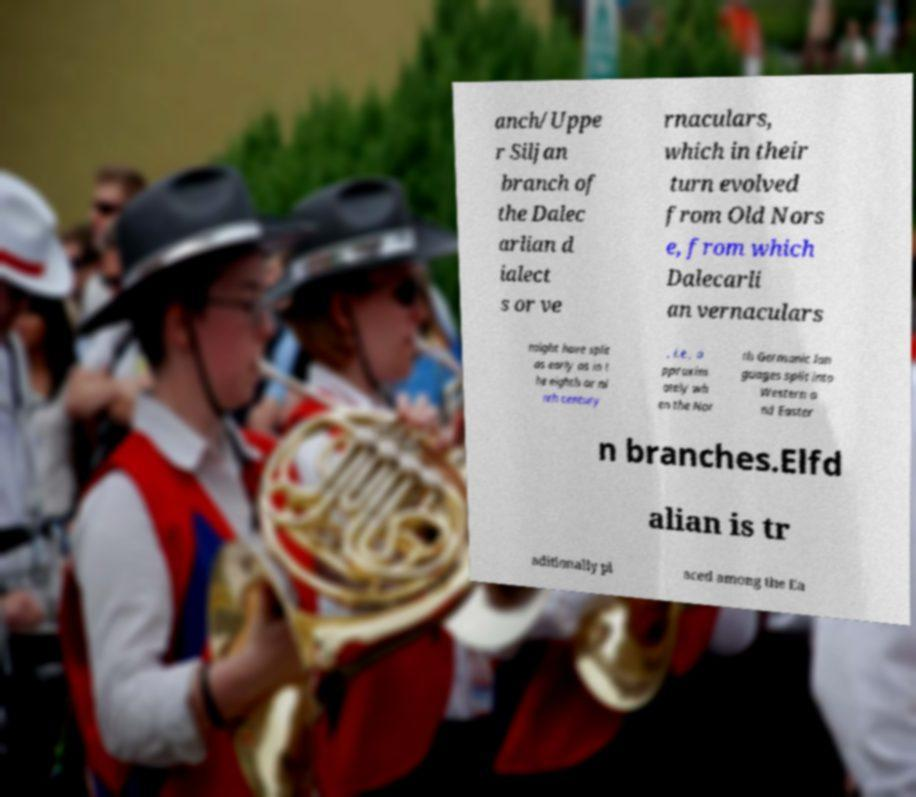Please identify and transcribe the text found in this image. anch/Uppe r Siljan branch of the Dalec arlian d ialect s or ve rnaculars, which in their turn evolved from Old Nors e, from which Dalecarli an vernaculars might have split as early as in t he eighth or ni nth century , i.e., a pproxim ately wh en the Nor th Germanic lan guages split into Western a nd Easter n branches.Elfd alian is tr aditionally pl aced among the Ea 